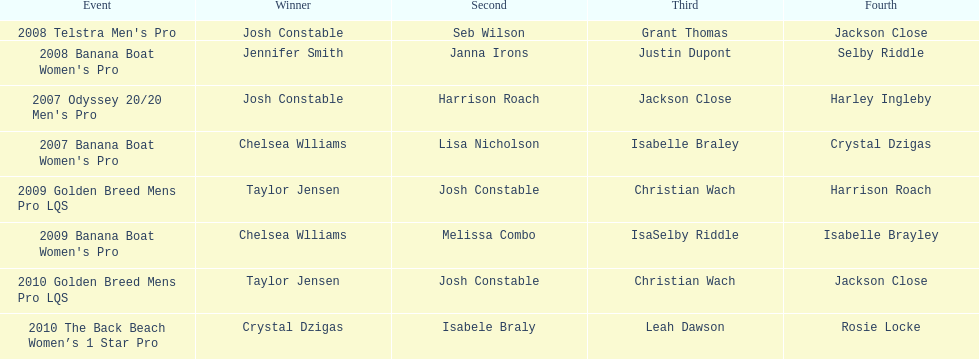In which years did taylor jensen emerge as the winner? 2009, 2010. 